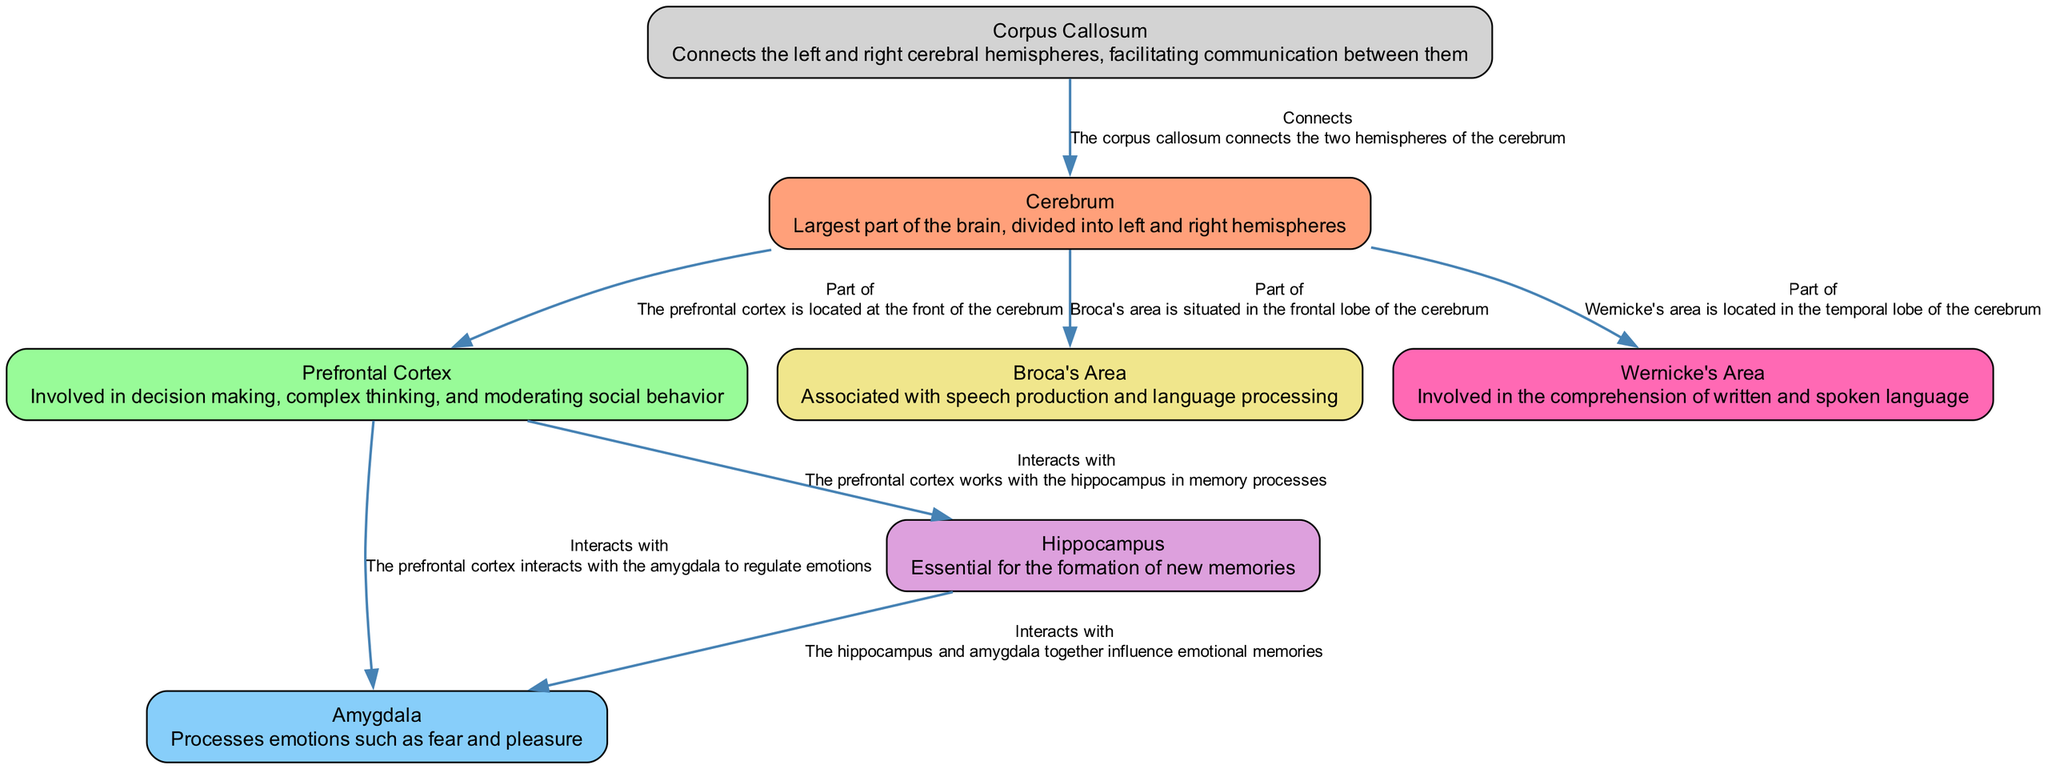What is the largest part of the brain? The diagram identifies the "Cerebrum" as the largest part of the brain, which is explicitly mentioned in its description.
Answer: Cerebrum Which region is responsible for decision-making and complex thinking? The "Prefrontal Cortex" is labeled in the diagram as involved in decision making and complex thinking, as stated in its associated description.
Answer: Prefrontal Cortex How many nodes are present in the diagram? The diagram lists 7 nodes, each representing a different region of the brain involved in creativity and emotional response. Counting these nodes confirms the total.
Answer: 7 What connects the left and right hemispheres of the cerebrum? The "Corpus Callosum" is depicted as the structure that connects the two hemispheres, noted in the description of the edge linking it to the cerebrum.
Answer: Corpus Callosum Which two areas interact to regulate emotions? The "Prefrontal Cortex" and "Amygdala" are shown to interact, as indicated in the edge linking the two and its description in the diagram.
Answer: Prefrontal Cortex and Amygdala What is the role of the Hippocampus in relation to emotional memories? The diagram states that the "Hippocampus" interacts with the "Amygdala" to influence emotional memories, indicating a collaborative role in memory processing.
Answer: Influences In which lobe of the cerebrum is Broca's area located? The diagram specifies that "Broca's Area" is situated in the frontal lobe of the cerebrum, as mentioned in the edge that connects it to the cerebrum.
Answer: Frontal lobe What does the Prefrontal Cortex work with in memory processes? The "Hippocampus" is listed in the diagram as interacting with the "Prefrontal Cortex" for memory processes, linking these two areas in their functionality.
Answer: Hippocampus 